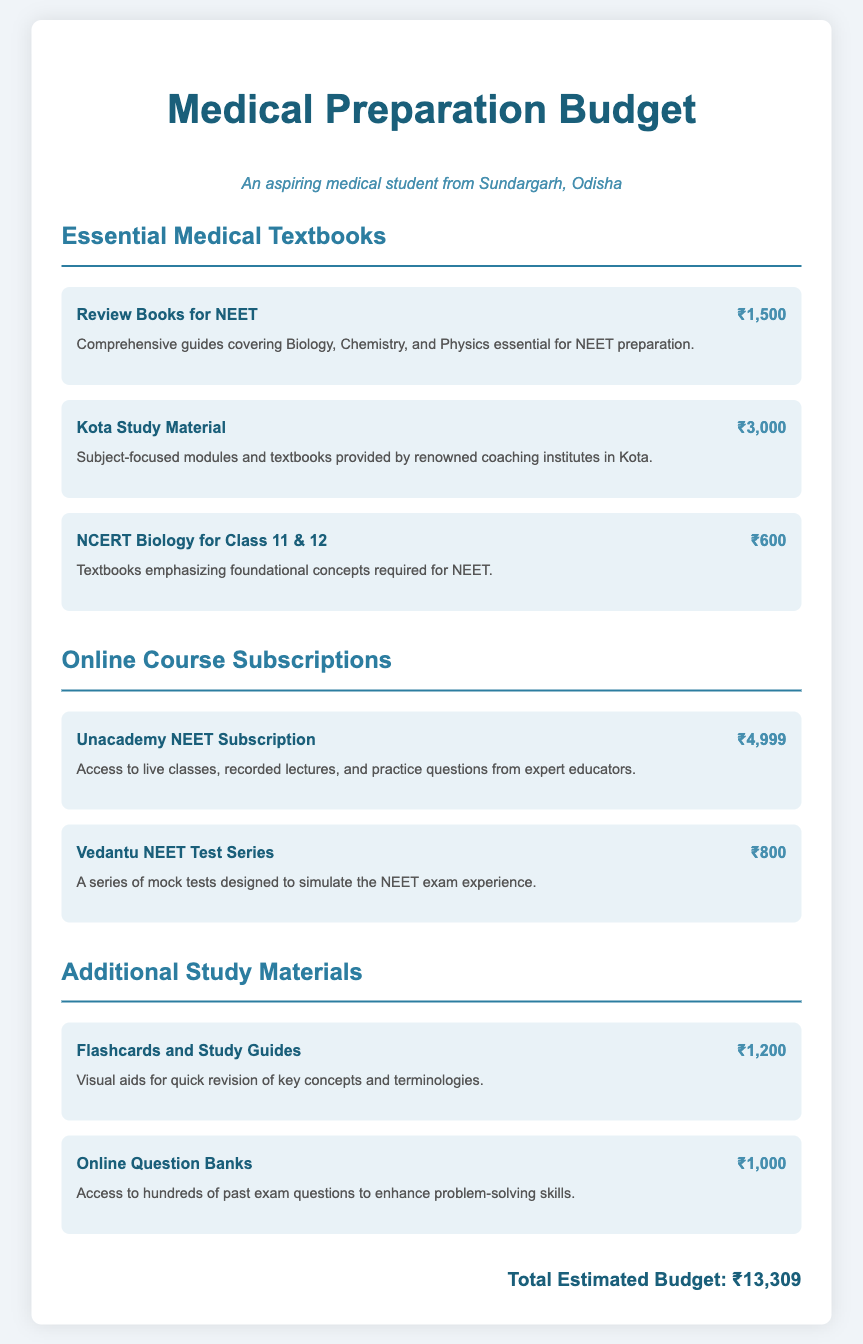what is the total estimated budget? The total estimated budget is displayed in the document, calculated from all expenses listed.
Answer: ₹13,309 how much does the Unacademy NEET Subscription cost? The cost of the Unacademy NEET Subscription is mentioned in the online course subscriptions section.
Answer: ₹4,999 what textbook is recommended for foundational concepts in Biology? The document specifies the NCERT Biology for Class 11 & 12 as essential for foundational concepts.
Answer: NCERT Biology for Class 11 & 12 how much are the flashcards and study guides? The amount for flashcards and study guides is listed under additional study materials.
Answer: ₹1,200 which online course provides a test series? The Vedantu NEET Test Series is explicitly mentioned as an online course that provides a test series.
Answer: Vedantu NEET Test Series what is the cost of Kota Study Material? The price of Kota Study Material can be found in the section on essential medical textbooks.
Answer: ₹3,000 how many items are listed in the online course subscriptions section? The document presents two distinct items under online course subscriptions.
Answer: 2 what type of materials are included in additional study materials? The additional study materials section includes flashcards and online question banks.
Answer: Flashcards and Study Guides, Online Question Banks which study resource costs the least among the items listed? The NCERT Biology for Class 11 & 12 is highlighted as the lowest cost item among all.
Answer: ₹600 